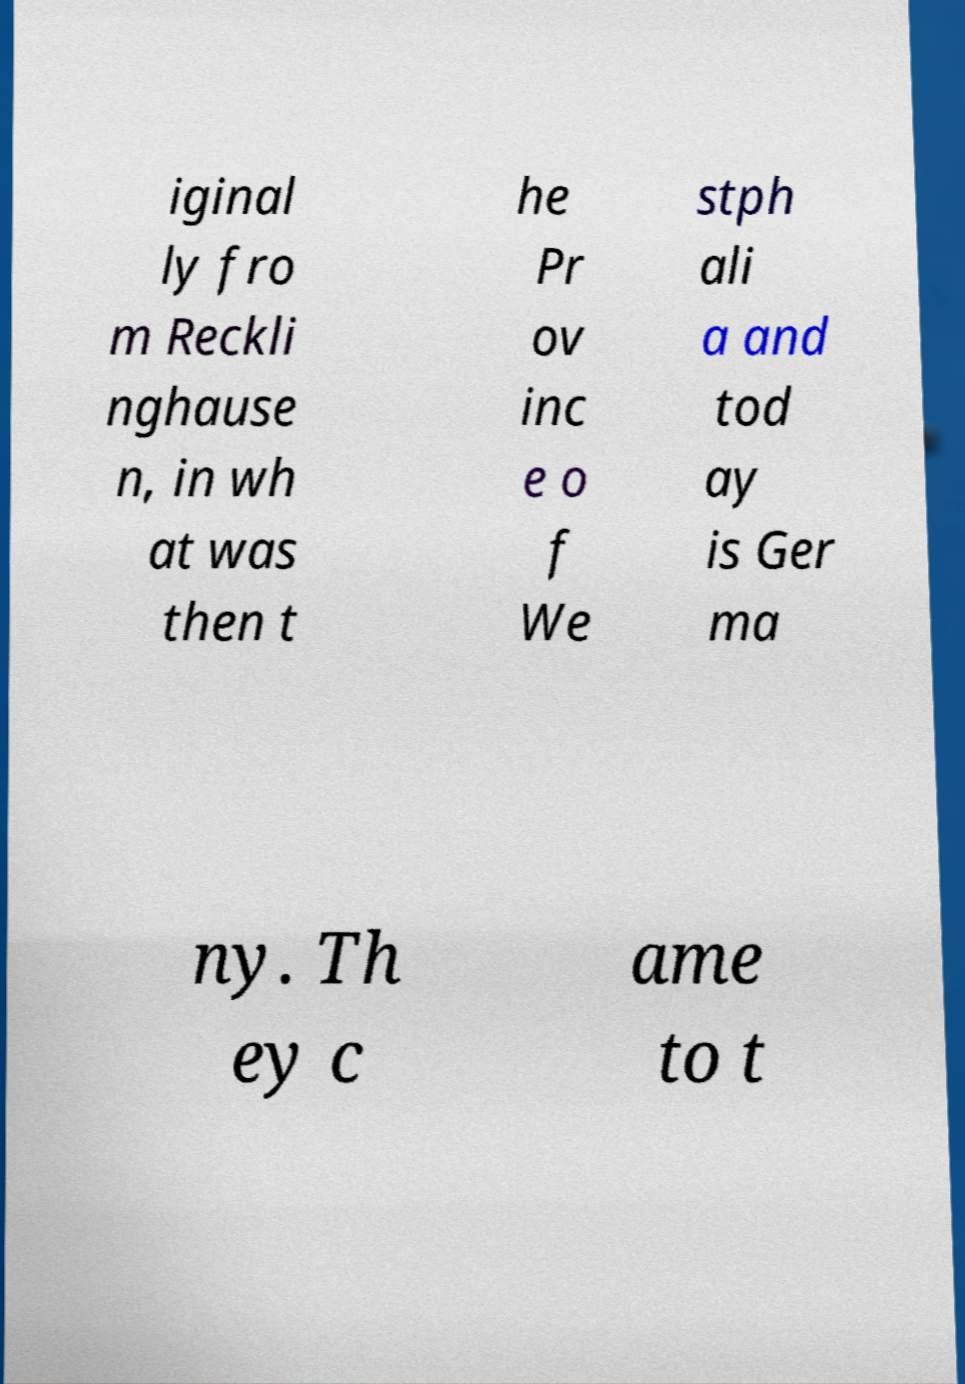There's text embedded in this image that I need extracted. Can you transcribe it verbatim? iginal ly fro m Reckli nghause n, in wh at was then t he Pr ov inc e o f We stph ali a and tod ay is Ger ma ny. Th ey c ame to t 